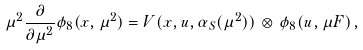Convert formula to latex. <formula><loc_0><loc_0><loc_500><loc_500>\mu ^ { 2 } \frac { \partial } { \partial \mu ^ { 2 } } \phi _ { 8 } ( x , \mu ^ { 2 } ) = V ( x , u , \alpha _ { S } ( \mu ^ { 2 } ) ) \, \otimes \, \phi _ { 8 } ( u , \mu F ) \, ,</formula> 